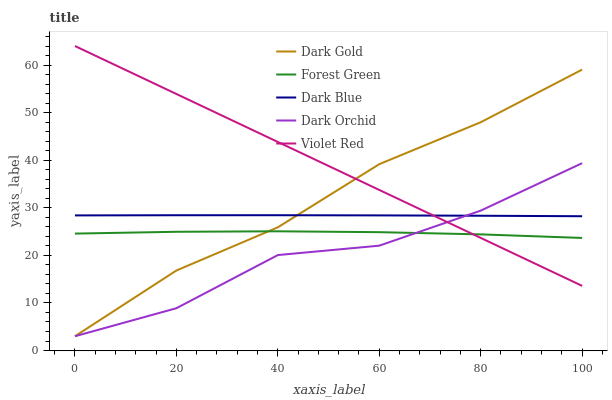Does Dark Orchid have the minimum area under the curve?
Answer yes or no. Yes. Does Violet Red have the maximum area under the curve?
Answer yes or no. Yes. Does Forest Green have the minimum area under the curve?
Answer yes or no. No. Does Forest Green have the maximum area under the curve?
Answer yes or no. No. Is Violet Red the smoothest?
Answer yes or no. Yes. Is Dark Orchid the roughest?
Answer yes or no. Yes. Is Forest Green the smoothest?
Answer yes or no. No. Is Forest Green the roughest?
Answer yes or no. No. Does Dark Orchid have the lowest value?
Answer yes or no. Yes. Does Forest Green have the lowest value?
Answer yes or no. No. Does Violet Red have the highest value?
Answer yes or no. Yes. Does Forest Green have the highest value?
Answer yes or no. No. Is Forest Green less than Dark Blue?
Answer yes or no. Yes. Is Dark Blue greater than Forest Green?
Answer yes or no. Yes. Does Violet Red intersect Dark Gold?
Answer yes or no. Yes. Is Violet Red less than Dark Gold?
Answer yes or no. No. Is Violet Red greater than Dark Gold?
Answer yes or no. No. Does Forest Green intersect Dark Blue?
Answer yes or no. No. 